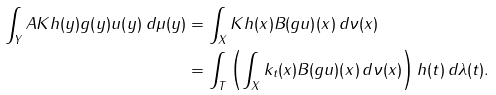Convert formula to latex. <formula><loc_0><loc_0><loc_500><loc_500>\int _ { Y } A K h ( y ) g ( y ) u ( y ) \, d \mu ( y ) & = \int _ { X } K h ( x ) B ( g u ) ( x ) \, d \nu ( x ) \\ & = \int _ { T } \left ( \int _ { X } k _ { t } ( x ) B ( g u ) ( x ) \, d \nu ( x ) \right ) h ( t ) \, d \lambda ( t ) .</formula> 